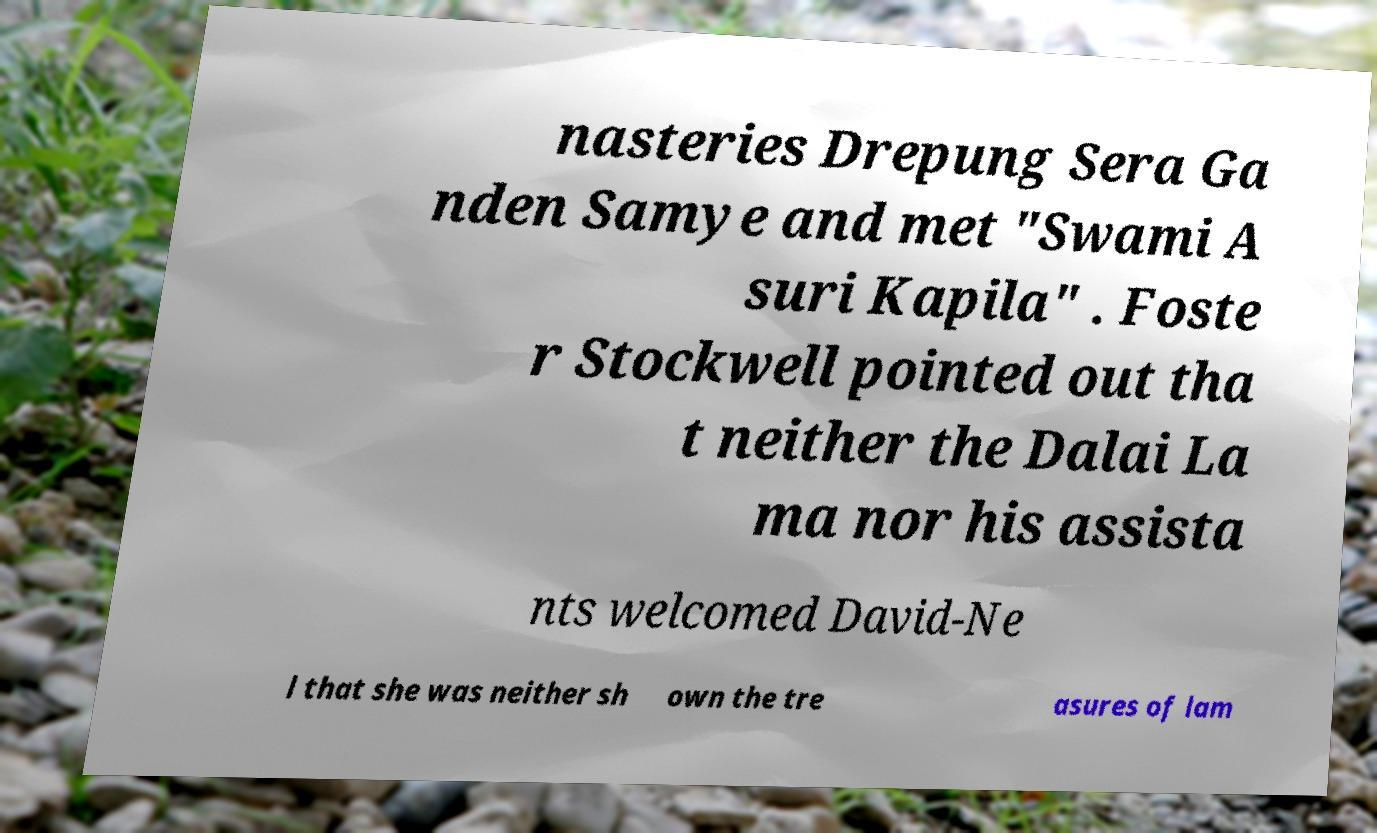For documentation purposes, I need the text within this image transcribed. Could you provide that? nasteries Drepung Sera Ga nden Samye and met "Swami A suri Kapila" . Foste r Stockwell pointed out tha t neither the Dalai La ma nor his assista nts welcomed David-Ne l that she was neither sh own the tre asures of lam 